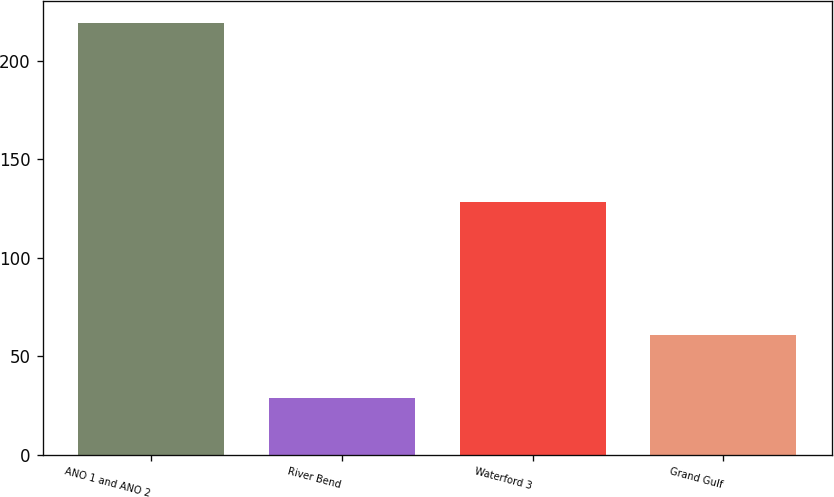Convert chart. <chart><loc_0><loc_0><loc_500><loc_500><bar_chart><fcel>ANO 1 and ANO 2<fcel>River Bend<fcel>Waterford 3<fcel>Grand Gulf<nl><fcel>219.1<fcel>28.7<fcel>128.5<fcel>60.8<nl></chart> 